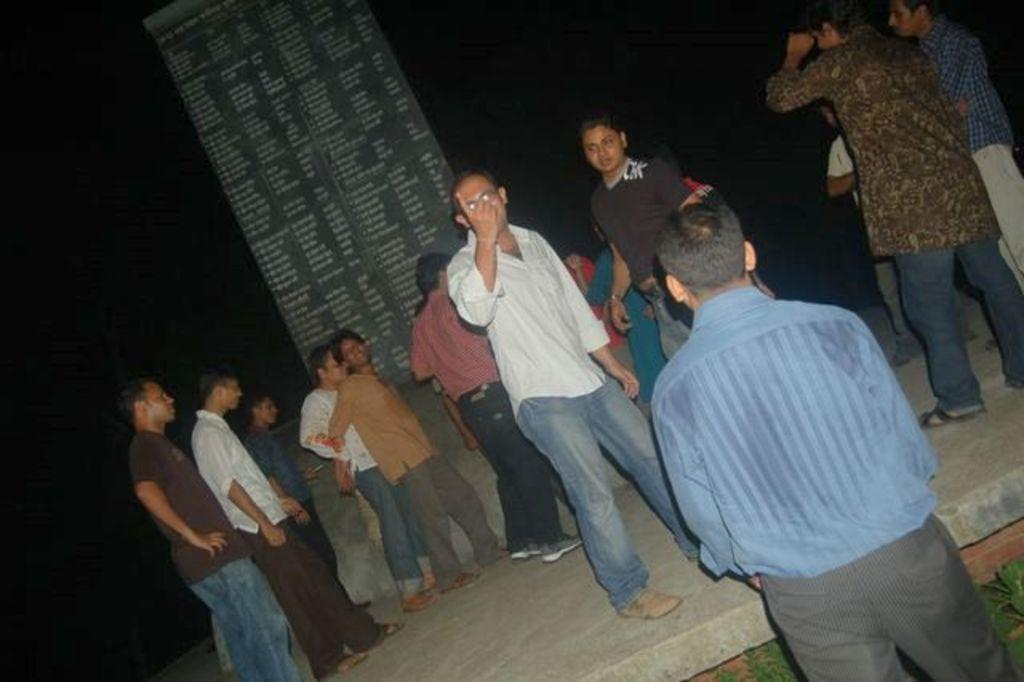How many people are in the image? There is a group of people standing in the image, but the exact number cannot be determined from the provided facts. What are the people doing in the image? The people are standing on the floor in the image. What can be seen in the middle of the image? There is a board visible in the middle of the image. What is the color of the background in the image? The background of the image is dark. What type of cover is being stitched by the people in the image? There is no mention of a cover or stitching in the provided facts, and therefore no such activity can be observed in the image. 